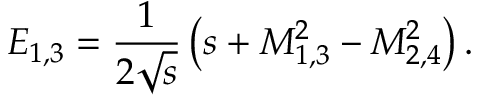<formula> <loc_0><loc_0><loc_500><loc_500>E _ { 1 , 3 } = \frac { 1 } { 2 \sqrt { s } } \left ( s + M _ { 1 , 3 } ^ { 2 } - M _ { 2 , 4 } ^ { 2 } \right ) .</formula> 